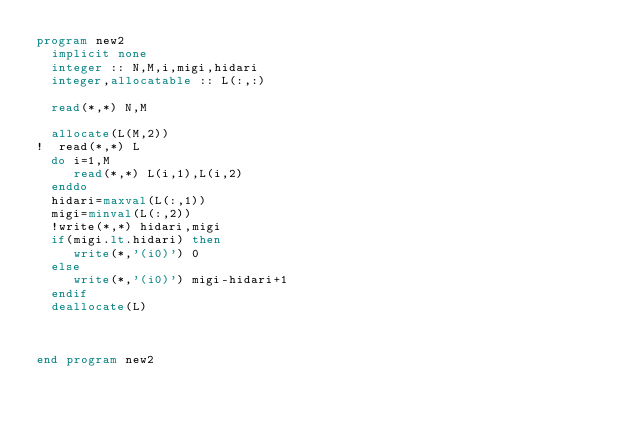Convert code to text. <code><loc_0><loc_0><loc_500><loc_500><_FORTRAN_>program new2
  implicit none
  integer :: N,M,i,migi,hidari
  integer,allocatable :: L(:,:)

  read(*,*) N,M

  allocate(L(M,2))
!  read(*,*) L                                                                                                                                           
  do i=1,M
     read(*,*) L(i,1),L(i,2)
  enddo
  hidari=maxval(L(:,1))
  migi=minval(L(:,2))
  !write(*,*) hidari,migi                                                                                                                                
  if(migi.lt.hidari) then
     write(*,'(i0)') 0
  else
     write(*,'(i0)') migi-hidari+1
  endif
  deallocate(L)



end program new2



</code> 